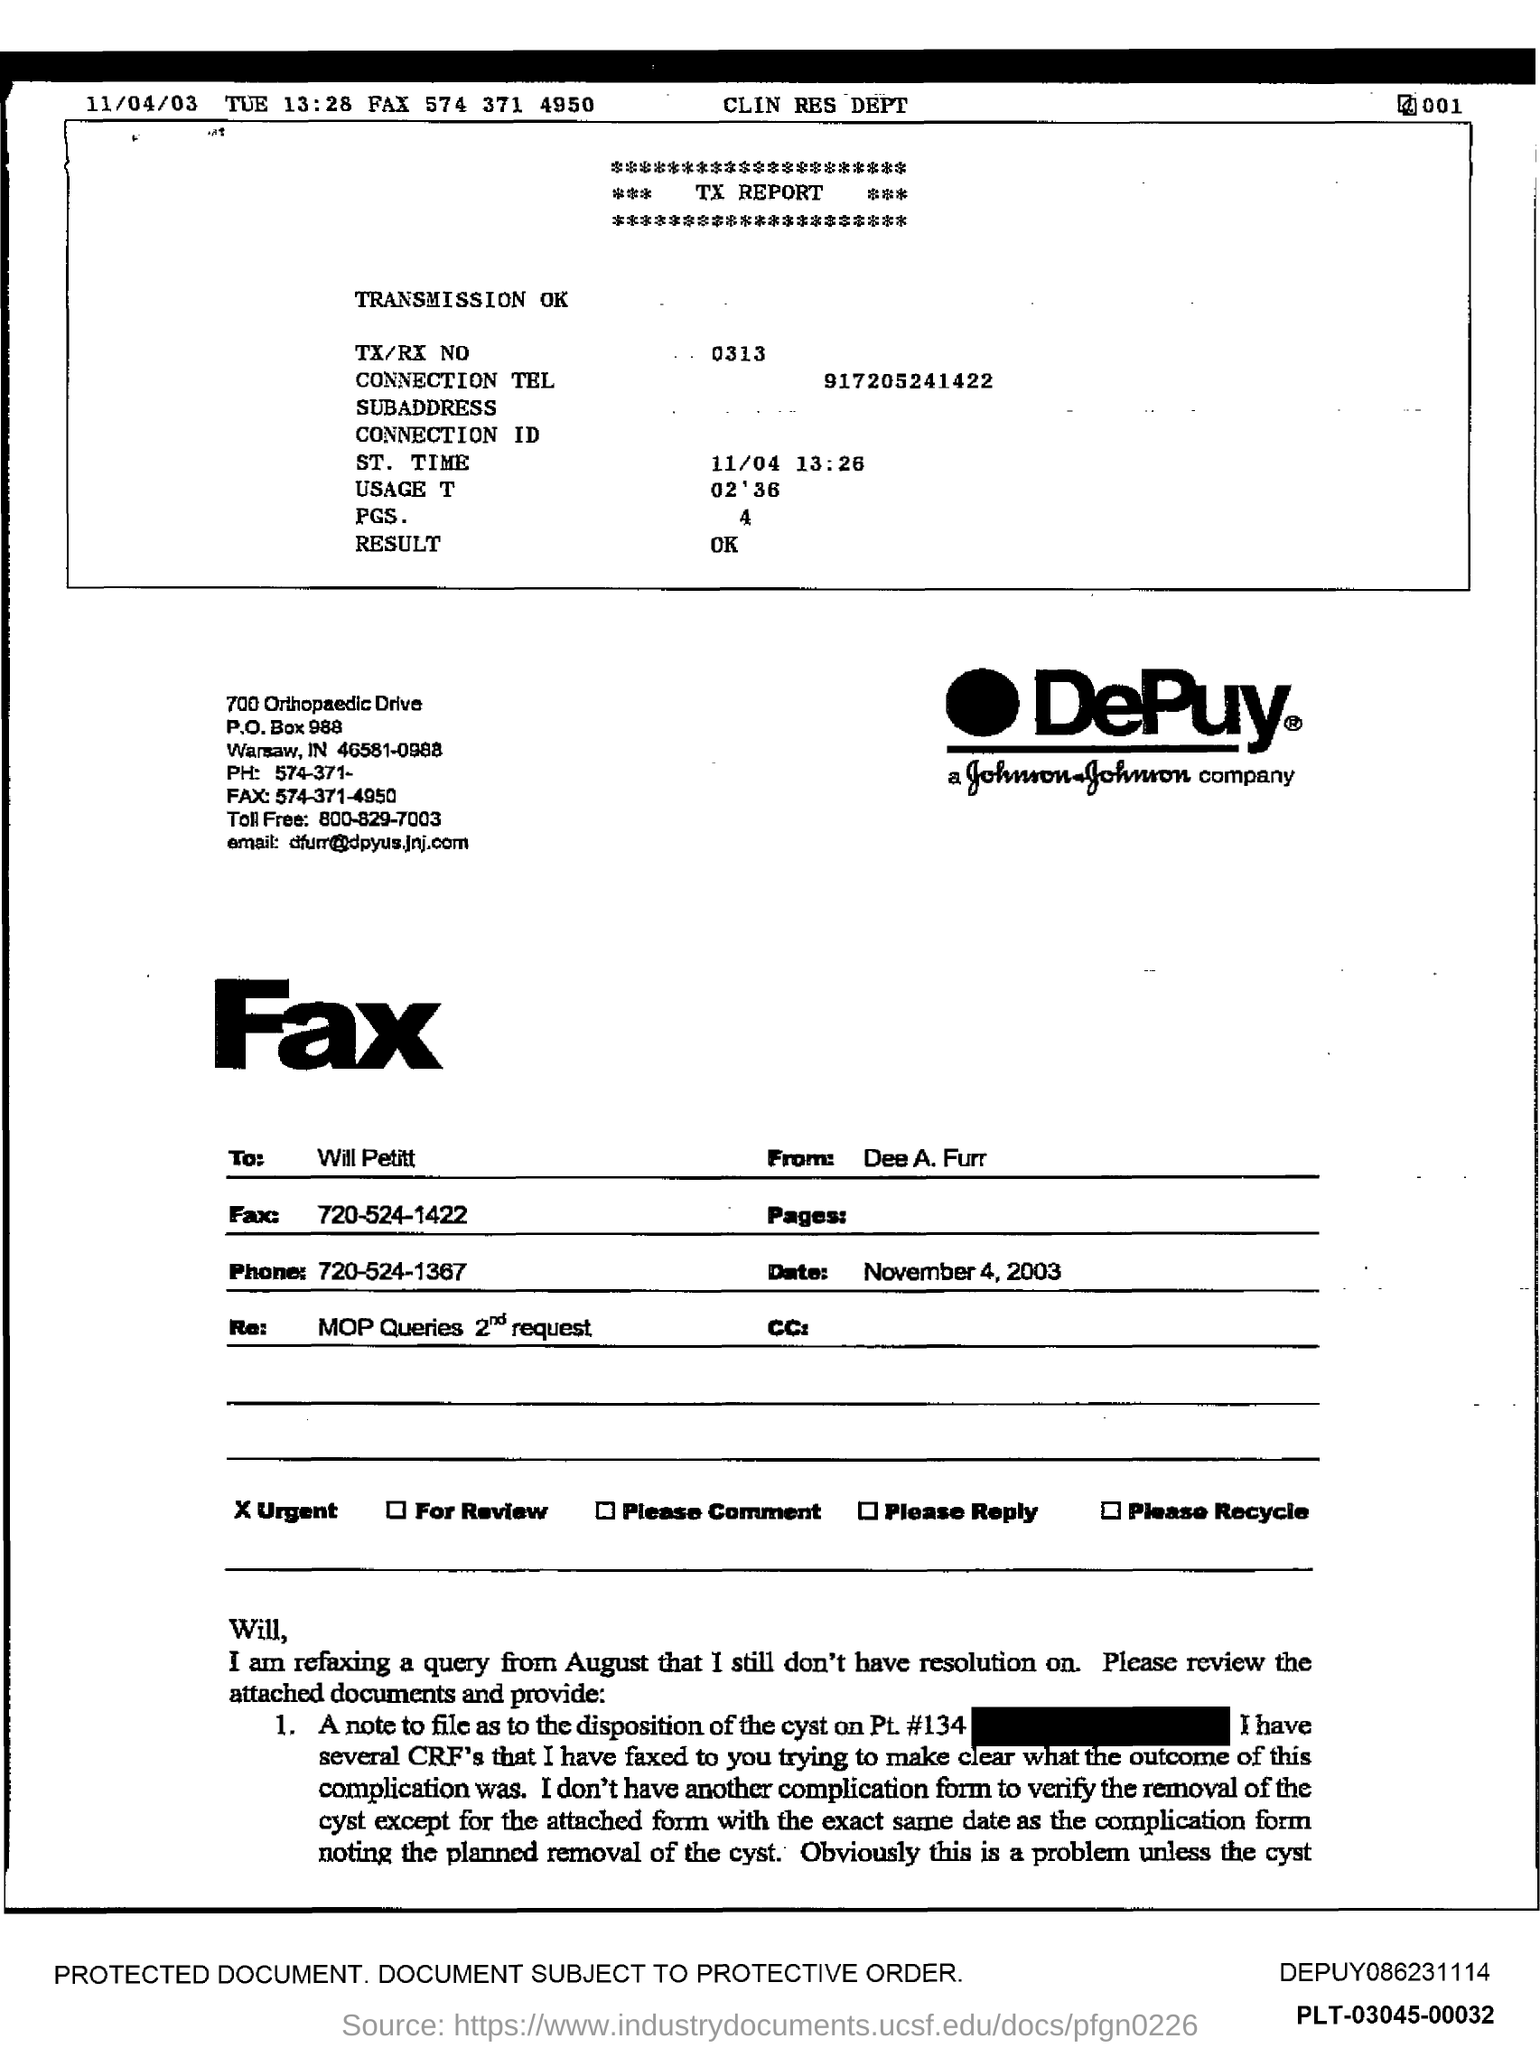What company sent this fax, and can you tell me more about them? The fax was sent by DePuy, a subsidiary of Johnson & Johnson, which specializes in orthopedic and neurological products. 